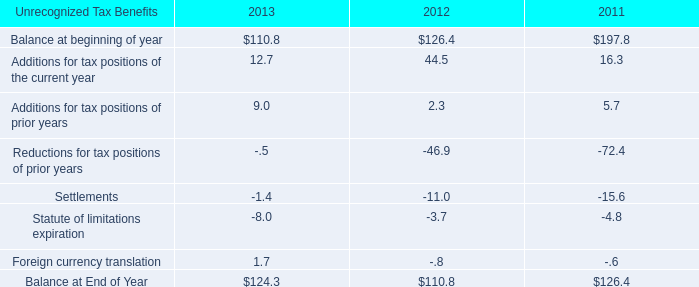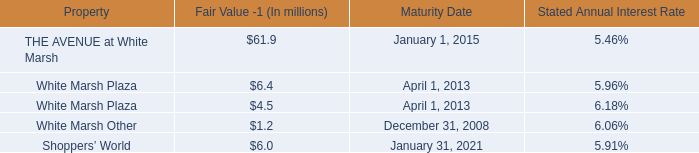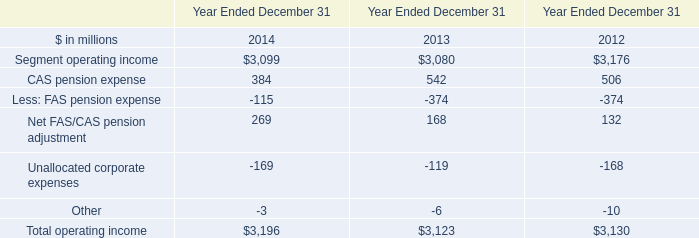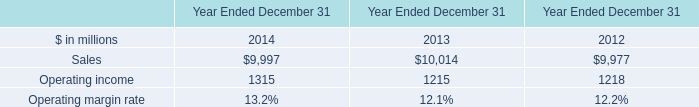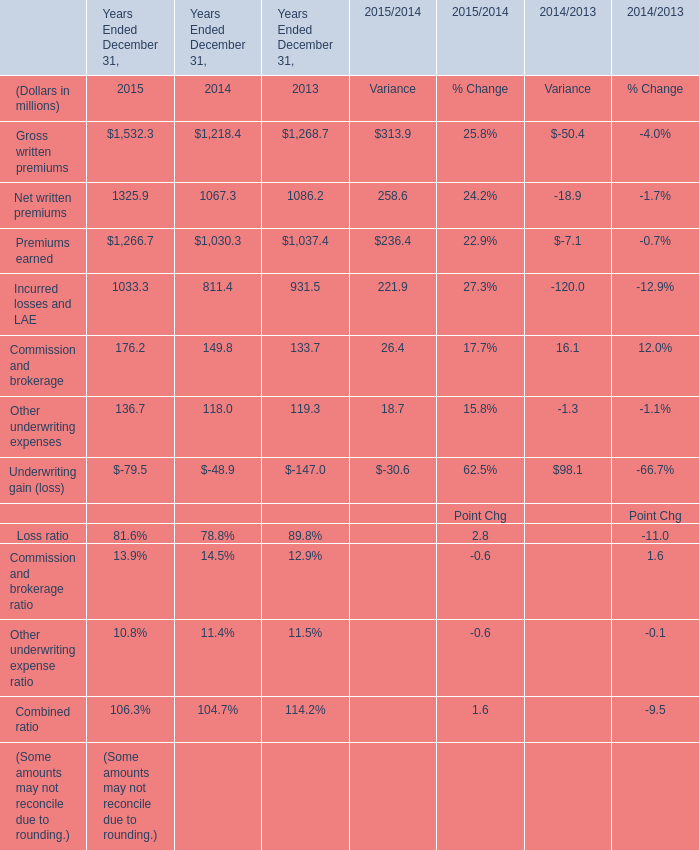What is the growing rate of Incurred losses and LAE in Table 4 in the year with the most Operating income in Table 3? 
Computations: ((811.4 - 931.5) / 931.5)
Answer: -0.12893. 